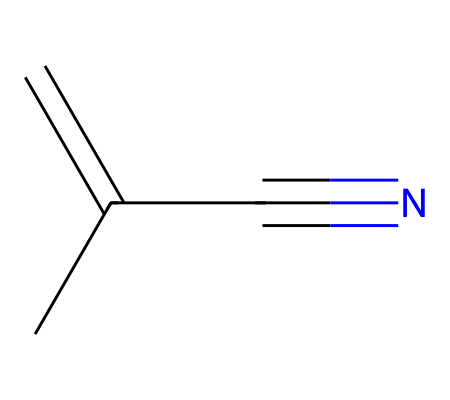What is the main functional group in methacrylonitrile? In the given structure, the presence of the -C#N group (nitrile group) indicates that this is a nitrile compound. The nitrile functional group consists of a carbon triple-bonded to a nitrogen atom.
Answer: nitrile How many carbon atoms are present in methacrylonitrile? By analyzing the SMILES representation, there are three carbon atoms in the main chain (C=C(C)) and one more in the -C#N group, leading to a total of four carbon atoms in the structure.
Answer: four What type of hybridization is present at the carbon atoms of the nitrile functional group? The carbon in the nitrile (-C#N) is triple-bonded to the nitrogen atom, which involves sp hybridization because it has two other bonds: one with the nitrogen and one with another carbon.
Answer: sp Are there any double bonds in methacrylonitrile? The structure includes a double bond between the first and second carbon atoms (C=C), indicating the presence of an alkene characteristic of methacrylonitrile.
Answer: yes How does methacrylonitrile contribute to the properties of clear plastics? Methacrylonitrile's structure facilitates polymerization, leading to strong and transparent materials that are resistant to impact and UV light, making them suitable for clear plastics.
Answer: polymerization What type of molecular structure does methacrylonitrile represent? The structure represents an unsaturated organic compound due to the presence of the double bond between the carbons and the nitrile functional group, characterizing it as a nitrile.
Answer: unsaturated 